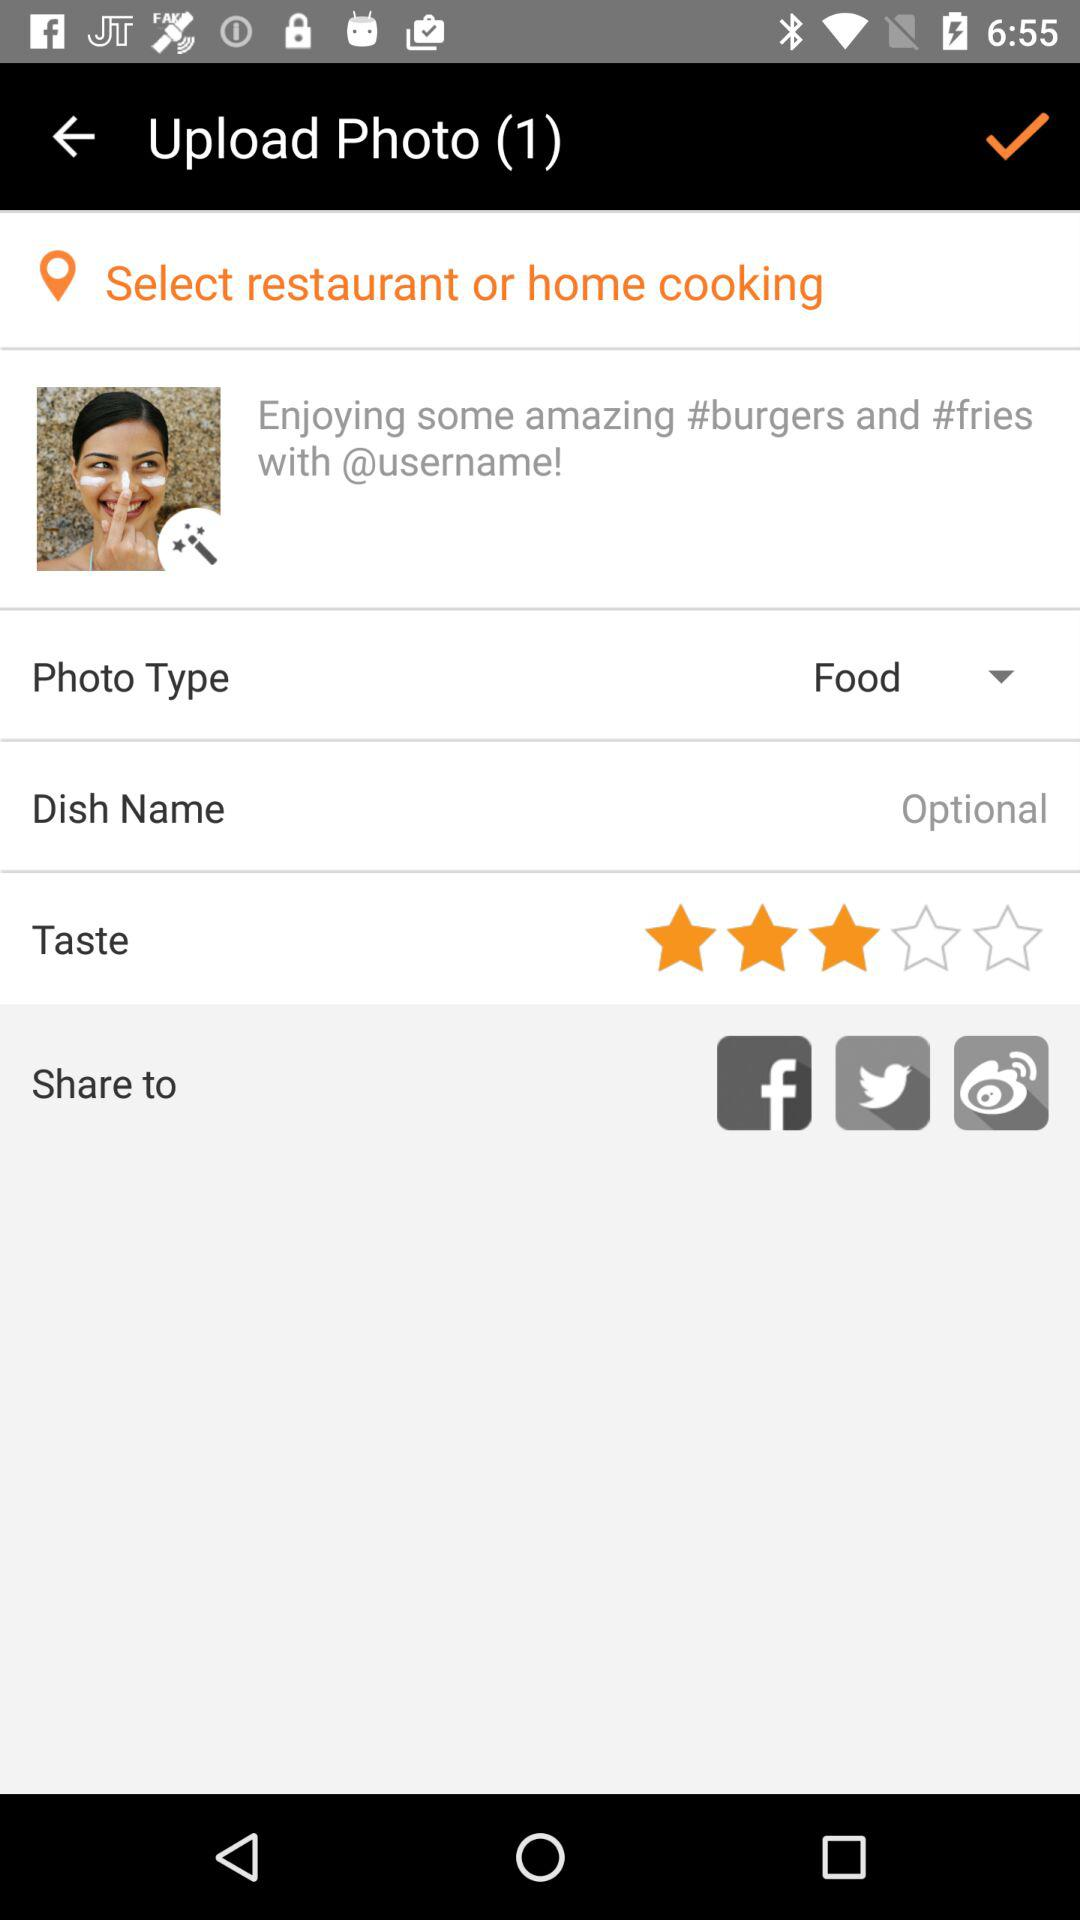What is the number of photos uploaded? The number of photos uploaded is 1. 